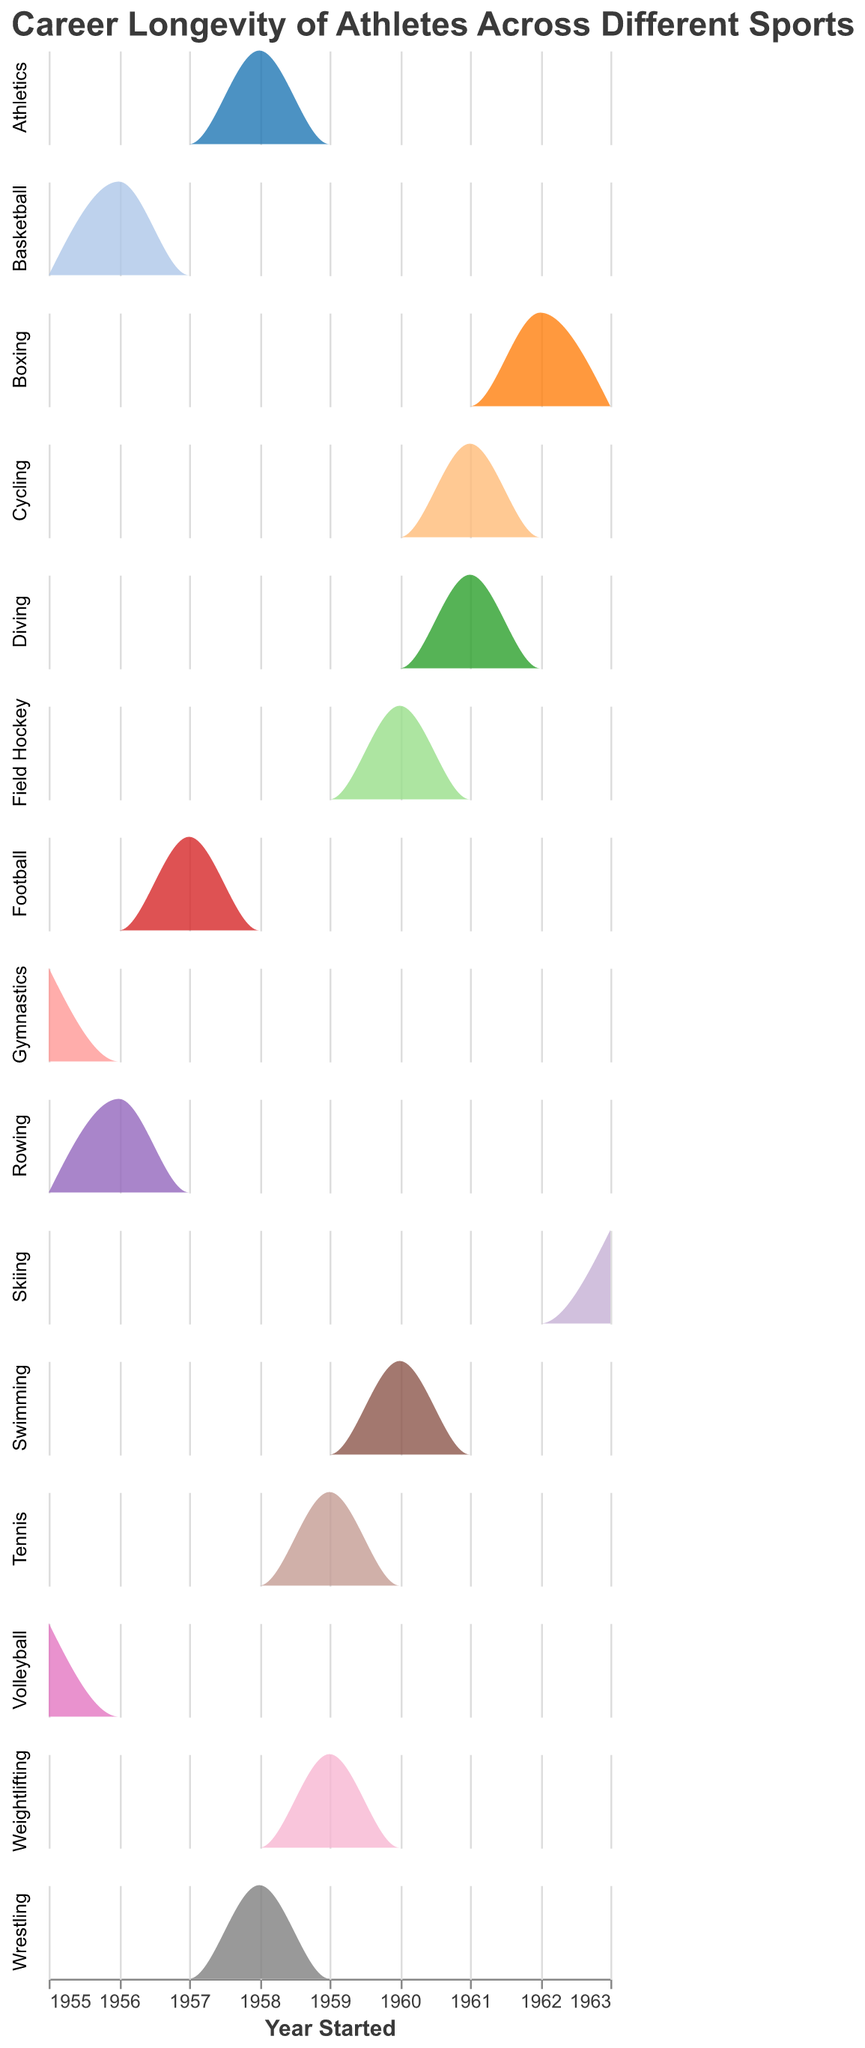How many sports are displayed in the figure? The figure shows each sport as a separate row in the subplot. By counting the rows, you can determine the number of sports represented.
Answer: 15 What sport has athletes starting in the most recent year? By checking the 'Year Started' along the x-axis for each sport, it becomes clear that 'Skiing' has the most recent start year of 1963.
Answer: Skiing Which sport has the highest peak in athlete count by year started? By visually comparing the height of the density plots for each sport, you can see that 'Skiing' has the highest peak.
Answer: Skiing Compare the career longevity of athletes in 'Football' and 'Basketball'. Which sport has a longer average career span? In 'Football', the athletes started in 1957 and retired in 1966, giving them a career span of 9 years. For 'Basketball', they started in 1956 and retired in 1965, also spanning 9 years.
Answer: Equal Which sport saw the largest number of athletes start in 1960? By looking at the density plots and focusing on the year 1960 along the x-axis, you can see that 'Swimming' and 'Field Hockey' have peaks that align with 1960, indicating athletes started that year.
Answer: Swimming and Field Hockey How does the career longevity of 'Boxing' compare to 'Volleyball'? Athletes in 'Boxing' started in 1962 and retired in 1970, giving them a career span of 8 years. 'Volleyball' athletes started in 1955 and retired in 1964, which is a span of 9 years. Volleyball has a slightly longer average career span than Boxing.
Answer: Volleyball Which sport has athletes with the shortest average career span? By checking the difference between the 'Year Started' and 'Year Retired' for each sport, 'Gymnastics' with athletes starting in 1955 and retiring in 1962 has a career span of 7 years, the shortest among the sports listed.
Answer: Gymnastics Which year shows the greatest variety of sports with athletes starting their careers? By looking at the density plots across different sports, we see that the year 1960 has several sports including 'Swimming', 'Field Hockey', and 'Weightlifting' with athletes starting their careers.
Answer: 1960 